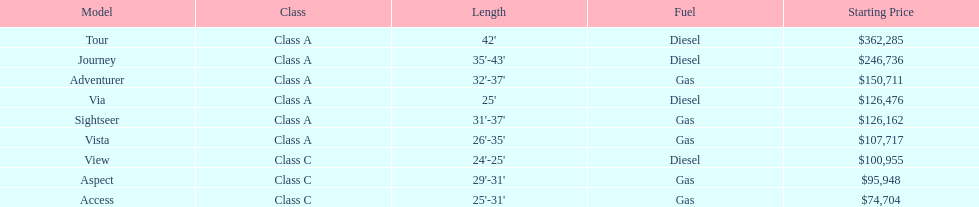Would you mind parsing the complete table? {'header': ['Model', 'Class', 'Length', 'Fuel', 'Starting Price'], 'rows': [['Tour', 'Class A', "42'", 'Diesel', '$362,285'], ['Journey', 'Class A', "35'-43'", 'Diesel', '$246,736'], ['Adventurer', 'Class A', "32'-37'", 'Gas', '$150,711'], ['Via', 'Class A', "25'", 'Diesel', '$126,476'], ['Sightseer', 'Class A', "31'-37'", 'Gas', '$126,162'], ['Vista', 'Class A', "26'-35'", 'Gas', '$107,717'], ['View', 'Class C', "24'-25'", 'Diesel', '$100,955'], ['Aspect', 'Class C', "29'-31'", 'Gas', '$95,948'], ['Access', 'Class C', "25'-31'", 'Gas', '$74,704']]} How lengthy is the aspect? 29'-31'. 